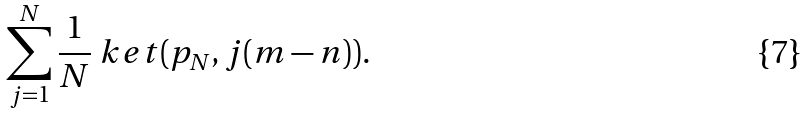Convert formula to latex. <formula><loc_0><loc_0><loc_500><loc_500>\sum _ { j = 1 } ^ { N } \frac { 1 } { N } \ k e t { ( p _ { N } , j ( m - n ) ) } .</formula> 